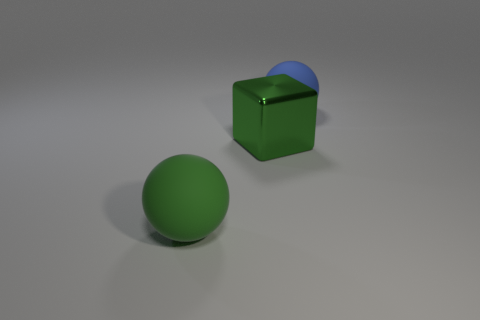Is there anything else that has the same shape as the green shiny object?
Your response must be concise. No. The matte object in front of the blue thing is what color?
Give a very brief answer. Green. Are there fewer big green rubber things that are on the right side of the big green shiny block than spheres to the left of the large blue object?
Your answer should be very brief. Yes. What number of other things are the same material as the blue thing?
Ensure brevity in your answer.  1. Does the green block have the same material as the large blue ball?
Your answer should be very brief. No. How many other objects are the same size as the blue object?
Give a very brief answer. 2. What size is the rubber thing in front of the big rubber sphere to the right of the green matte ball?
Offer a very short reply. Large. The big rubber sphere that is in front of the matte object that is to the right of the big matte object in front of the green metallic thing is what color?
Keep it short and to the point. Green. What size is the thing that is both behind the big green rubber ball and left of the large blue ball?
Ensure brevity in your answer.  Large. What number of other things are there of the same shape as the big green shiny thing?
Keep it short and to the point. 0. 